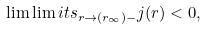Convert formula to latex. <formula><loc_0><loc_0><loc_500><loc_500>\lim \lim i t s _ { r \to ( r _ { \infty } ) - } j ( r ) < 0 ,</formula> 